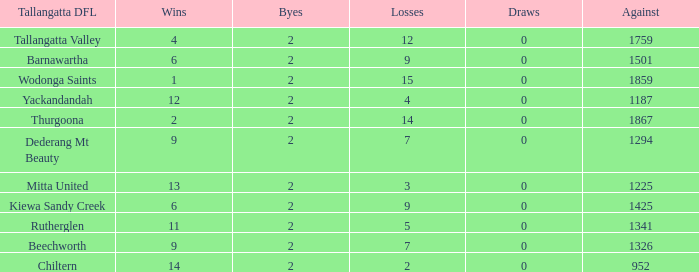What is the most byes with 11 wins and fewer than 1867 againsts? 2.0. 